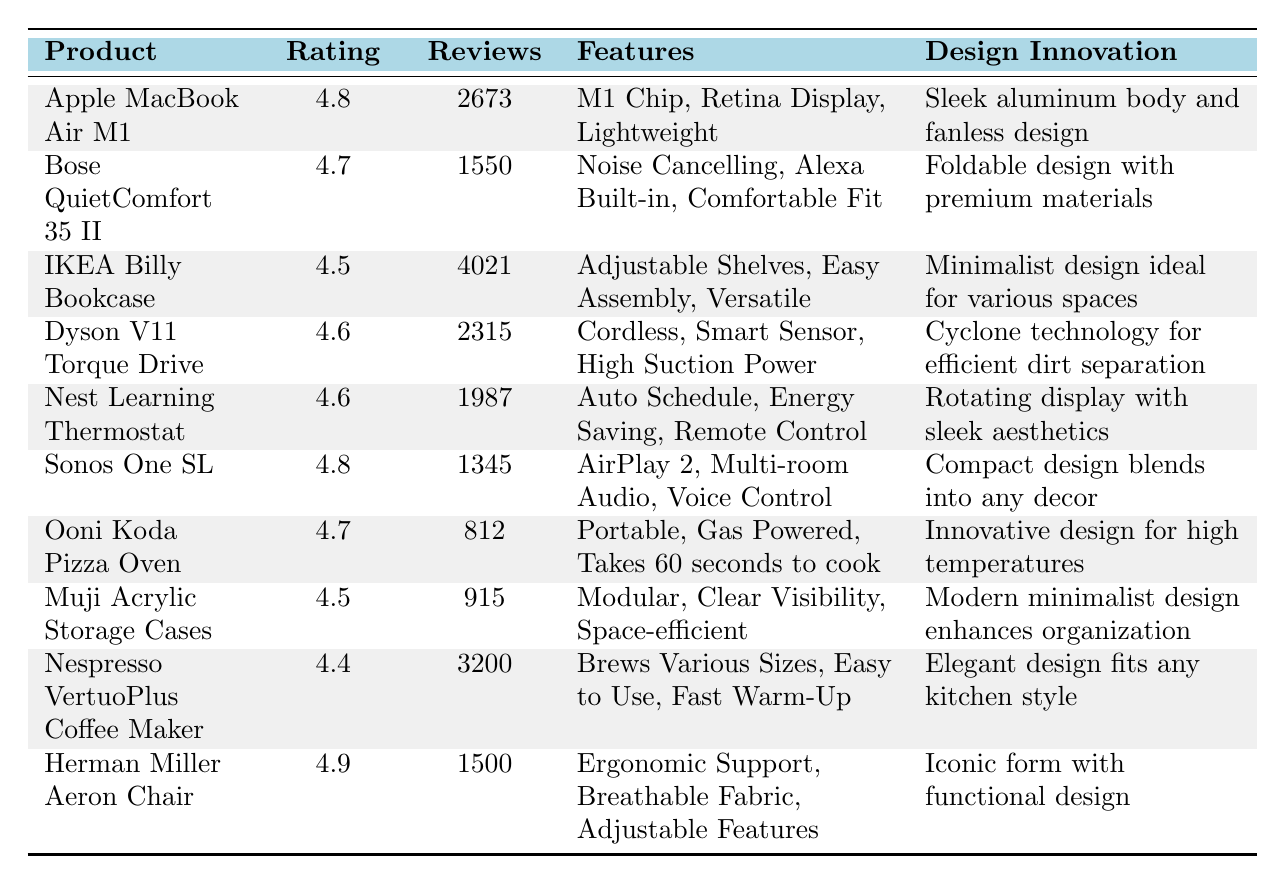What is the user rating of the Herman Miller Aeron Chair? The table shows the user rating of the Herman Miller Aeron Chair to be 4.9, which can be found in the "Rating" column next to its product name.
Answer: 4.9 Which product has the highest user reviews? The product with the highest user reviews is the IKEA Billy Bookcase, with a total of 4021 reviews listed in the "Reviews" column.
Answer: IKEA Billy Bookcase What is the average user rating of products in the "Smart Home" category? The only product in the "Smart Home" category is the Nest Learning Thermostat, which has a user rating of 4.6. As there is only one product, the average rating is simply 4.6.
Answer: 4.6 Does the Apple MacBook Air M1 have Noise Cancelling feature? No, the Apple MacBook Air M1 does not have the Noise Cancelling feature; this feature is listed under the Bose QuietComfort 35 II.
Answer: No How many products have a user rating of 4.6 or higher? By examining the table, there are 6 products with a user rating of 4.6 or higher: Apple MacBook Air M1, Bose QuietComfort 35 II, Dyson V11 Torque Drive, Nest Learning Thermostat, Sonos One SL, and Herman Miller Aeron Chair.
Answer: 6 What is the difference in user ratings between the highest and lowest-rated product? The highest-rated product is the Herman Miller Aeron Chair (4.9) and the lowest-rated product is the Nespresso VertuoPlus Coffee Maker (4.4). The difference is 4.9 - 4.4 = 0.5.
Answer: 0.5 What innovative design does the Ooni Koda Pizza Oven feature? The Ooni Koda Pizza Oven features an innovative design for high temperatures, as mentioned in the "Design Innovation" column.
Answer: Innovative design for high temperatures How many user reviews does the Sonos One SL have? The Sonos One SL has a total of 1345 user reviews, as indicated in the "Reviews" column.
Answer: 1345 Is the Nespresso VertuoPlus Coffee Maker the only product with a user rating below 4.5? No, the Nespresso VertuoPlus Coffee Maker is not the only product below 4.5; it has a rating of 4.4, but the Muji Acrylic Storage Cases also have a rating of 4.5, which is equal to the threshold, not below it.
Answer: No 